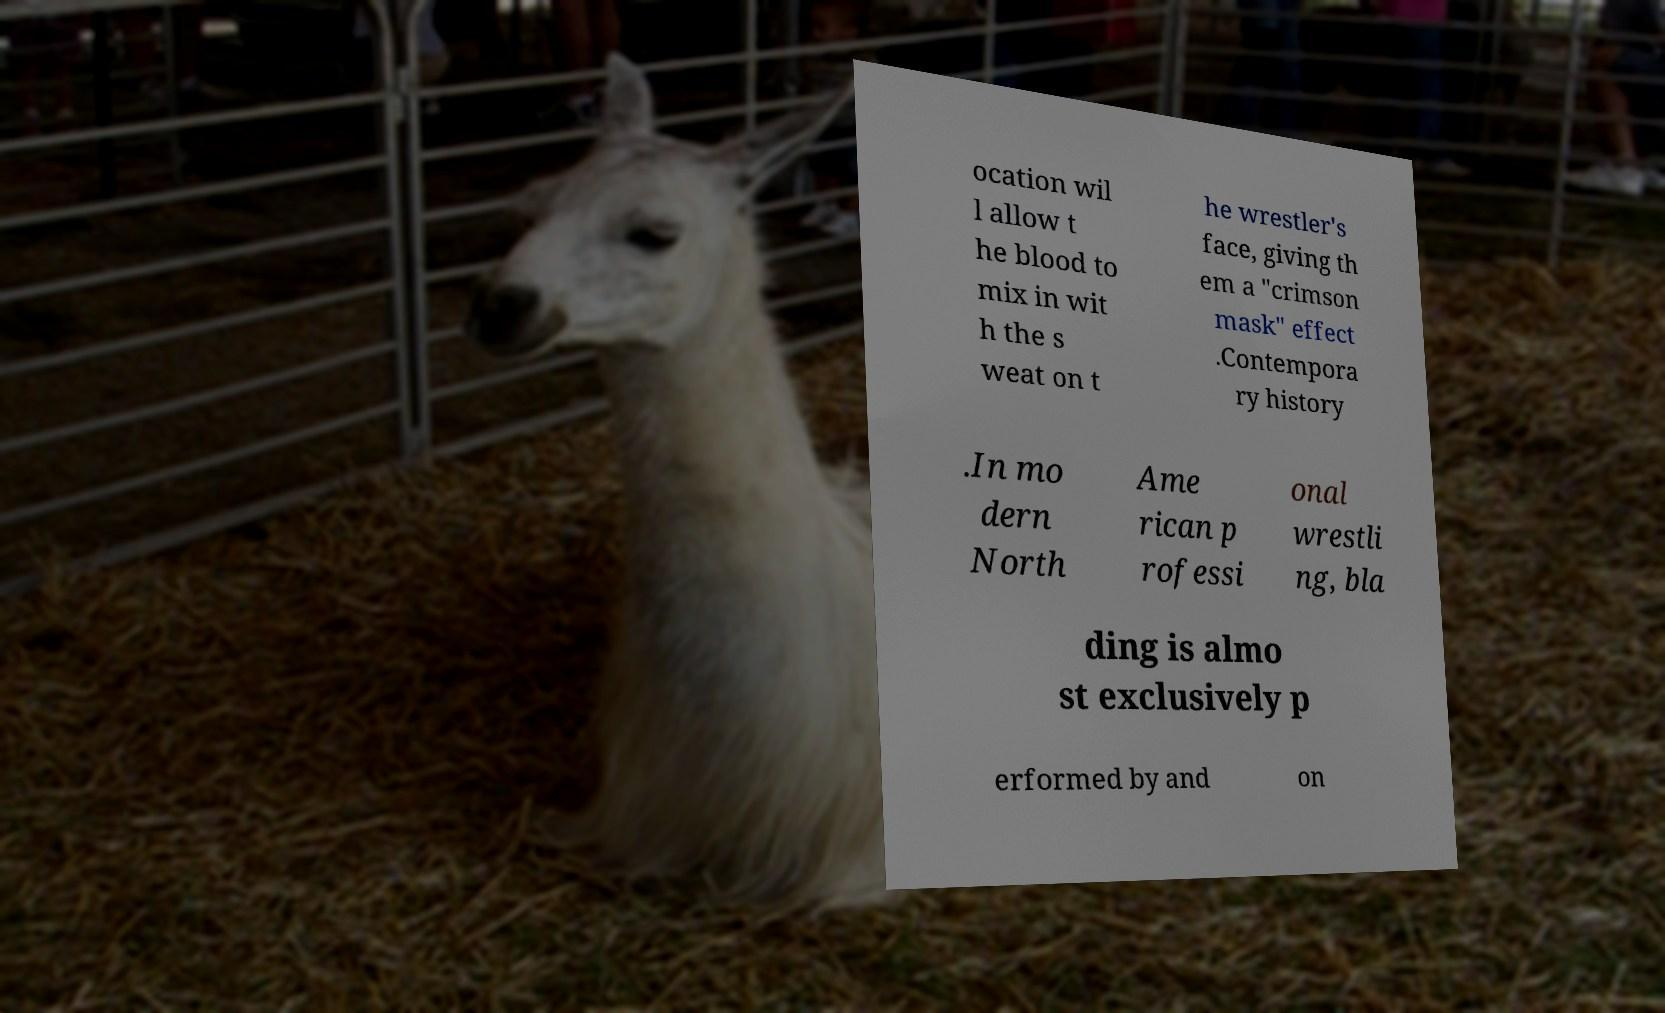Please read and relay the text visible in this image. What does it say? ocation wil l allow t he blood to mix in wit h the s weat on t he wrestler's face, giving th em a "crimson mask" effect .Contempora ry history .In mo dern North Ame rican p rofessi onal wrestli ng, bla ding is almo st exclusively p erformed by and on 